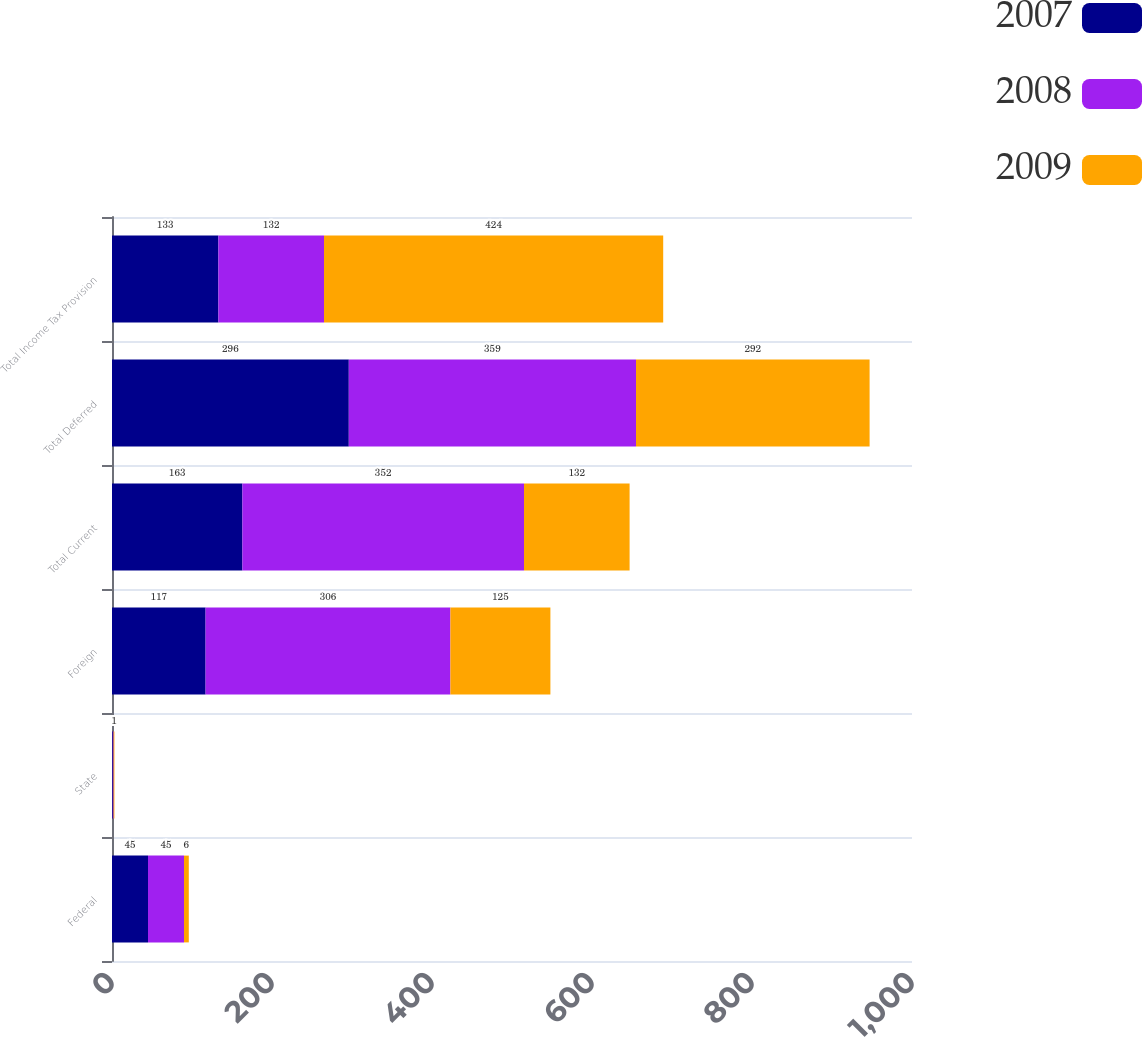Convert chart. <chart><loc_0><loc_0><loc_500><loc_500><stacked_bar_chart><ecel><fcel>Federal<fcel>State<fcel>Foreign<fcel>Total Current<fcel>Total Deferred<fcel>Total Income Tax Provision<nl><fcel>2007<fcel>45<fcel>1<fcel>117<fcel>163<fcel>296<fcel>133<nl><fcel>2008<fcel>45<fcel>1<fcel>306<fcel>352<fcel>359<fcel>132<nl><fcel>2009<fcel>6<fcel>1<fcel>125<fcel>132<fcel>292<fcel>424<nl></chart> 